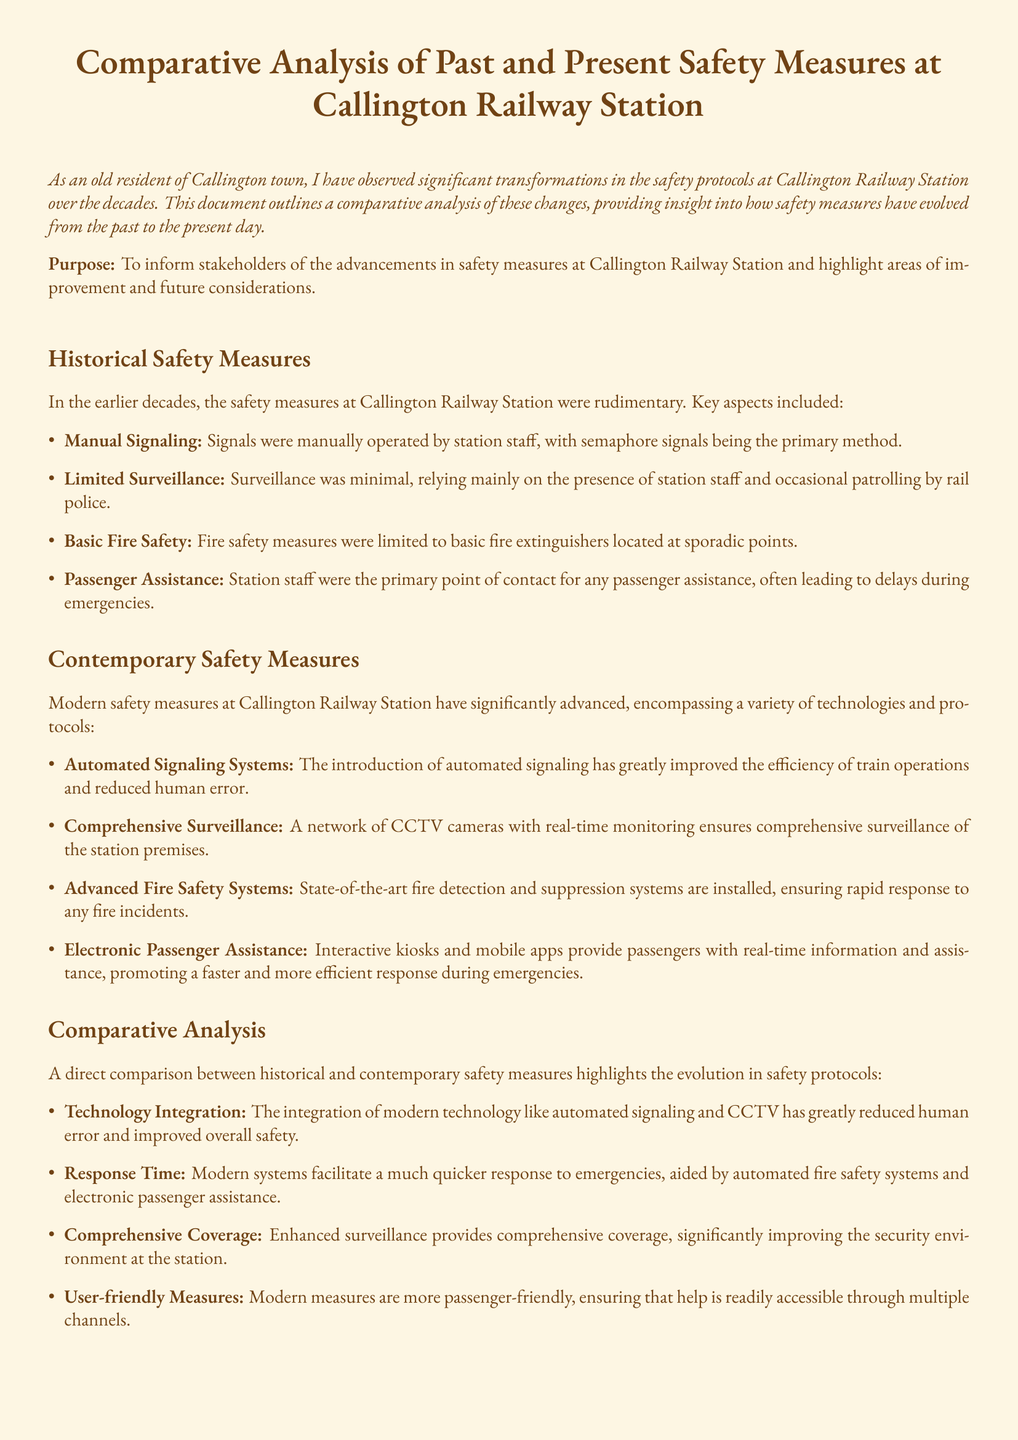what were the historical signaling methods used? The document states that the primary method was semaphore signals operated manually by station staff.
Answer: semaphore signals what has replaced manual signaling in contemporary measures? The document indicates that automated signaling systems have been introduced, replacing manual signaling.
Answer: automated signaling systems how is surveillance different now compared to the past? The document explains that contemporary surveillance includes a network of CCTV cameras with real-time monitoring, compared to minimal surveillance in the past.
Answer: CCTV cameras with real-time monitoring what advanced system is mentioned for fire safety today? The document describes state-of-the-art fire detection and suppression systems that ensure rapid response to fire incidents.
Answer: advanced fire safety systems how have passenger assistance methods evolved? The document mentions that modern systems utilize interactive kiosks and mobile apps for real-time information, as opposed to relying on station staff alone in the past.
Answer: interactive kiosks and mobile apps what is a key advantage of technology integration in safety measures? The document notes that technology integration has greatly reduced human error, improving overall safety.
Answer: reduced human error what does the document suggest about future safety measures? The document emphasizes the need for continuous assessment and upgrading of safety measures as technology evolves to address challenges.
Answer: continuous assessment and upgrading which demographic benefits from modern safety measures? The document indicates that all passengers benefit from the user-friendly nature of modern safety measures.
Answer: all passengers 